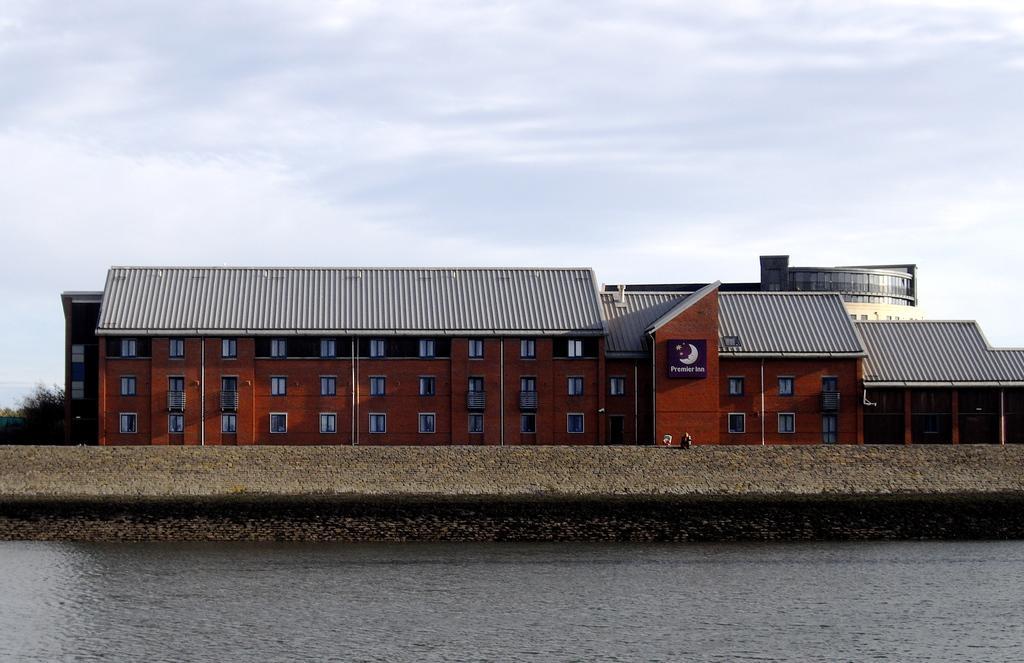Could you give a brief overview of what you see in this image? In the image there is a river and behind the river there is a building, it has many windows. 